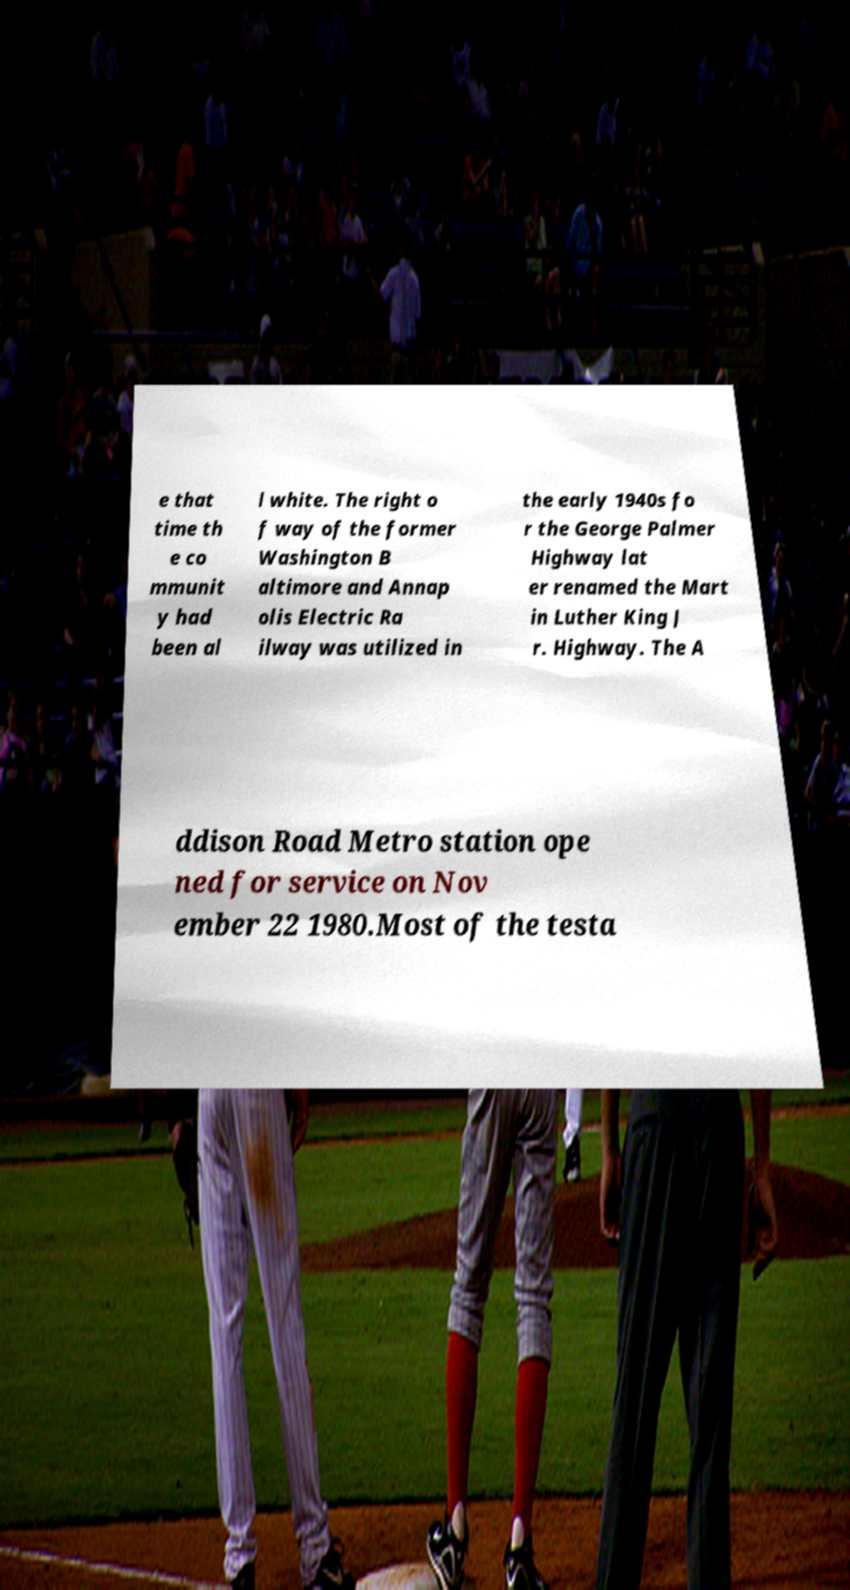Could you extract and type out the text from this image? e that time th e co mmunit y had been al l white. The right o f way of the former Washington B altimore and Annap olis Electric Ra ilway was utilized in the early 1940s fo r the George Palmer Highway lat er renamed the Mart in Luther King J r. Highway. The A ddison Road Metro station ope ned for service on Nov ember 22 1980.Most of the testa 